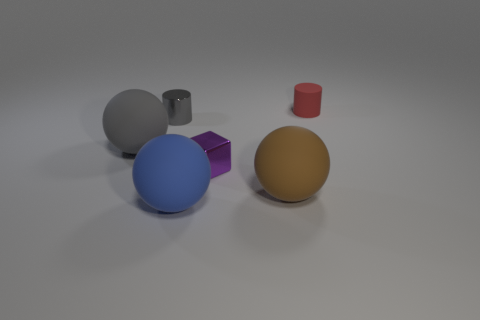Add 1 shiny objects. How many objects exist? 7 Subtract all cubes. How many objects are left? 5 Add 4 big brown spheres. How many big brown spheres exist? 5 Subtract 0 cyan balls. How many objects are left? 6 Subtract all gray metallic cylinders. Subtract all large brown matte things. How many objects are left? 4 Add 3 small red rubber cylinders. How many small red rubber cylinders are left? 4 